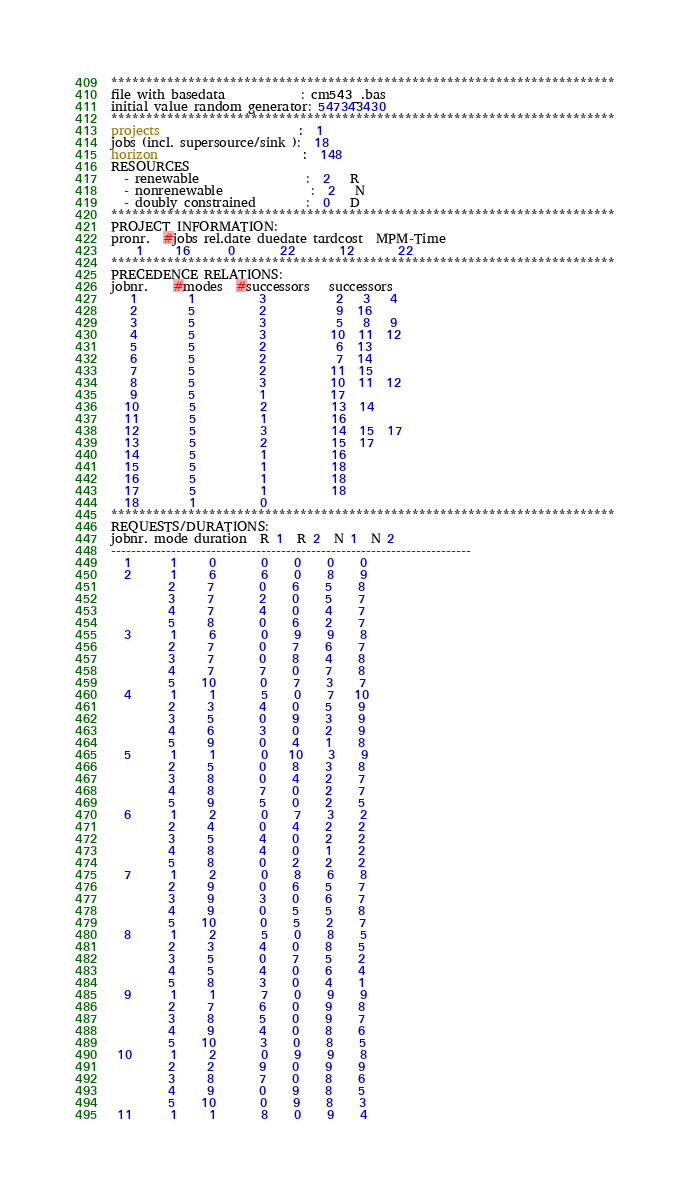<code> <loc_0><loc_0><loc_500><loc_500><_ObjectiveC_>************************************************************************
file with basedata            : cm543_.bas
initial value random generator: 547343430
************************************************************************
projects                      :  1
jobs (incl. supersource/sink ):  18
horizon                       :  148
RESOURCES
  - renewable                 :  2   R
  - nonrenewable              :  2   N
  - doubly constrained        :  0   D
************************************************************************
PROJECT INFORMATION:
pronr.  #jobs rel.date duedate tardcost  MPM-Time
    1     16      0       22       12       22
************************************************************************
PRECEDENCE RELATIONS:
jobnr.    #modes  #successors   successors
   1        1          3           2   3   4
   2        5          2           9  16
   3        5          3           5   8   9
   4        5          3          10  11  12
   5        5          2           6  13
   6        5          2           7  14
   7        5          2          11  15
   8        5          3          10  11  12
   9        5          1          17
  10        5          2          13  14
  11        5          1          16
  12        5          3          14  15  17
  13        5          2          15  17
  14        5          1          16
  15        5          1          18
  16        5          1          18
  17        5          1          18
  18        1          0        
************************************************************************
REQUESTS/DURATIONS:
jobnr. mode duration  R 1  R 2  N 1  N 2
------------------------------------------------------------------------
  1      1     0       0    0    0    0
  2      1     6       6    0    8    9
         2     7       0    6    5    8
         3     7       2    0    5    7
         4     7       4    0    4    7
         5     8       0    6    2    7
  3      1     6       0    9    9    8
         2     7       0    7    6    7
         3     7       0    8    4    8
         4     7       7    0    7    8
         5    10       0    7    3    7
  4      1     1       5    0    7   10
         2     3       4    0    5    9
         3     5       0    9    3    9
         4     6       3    0    2    9
         5     9       0    4    1    8
  5      1     1       0   10    3    9
         2     5       0    8    3    8
         3     8       0    4    2    7
         4     8       7    0    2    7
         5     9       5    0    2    5
  6      1     2       0    7    3    2
         2     4       0    4    2    2
         3     5       4    0    2    2
         4     8       4    0    1    2
         5     8       0    2    2    2
  7      1     2       0    8    6    8
         2     9       0    6    5    7
         3     9       3    0    6    7
         4     9       0    5    5    8
         5    10       0    5    2    7
  8      1     2       5    0    8    5
         2     3       4    0    8    5
         3     5       0    7    5    2
         4     5       4    0    6    4
         5     8       3    0    4    1
  9      1     1       7    0    9    9
         2     7       6    0    9    8
         3     8       5    0    9    7
         4     9       4    0    8    6
         5    10       3    0    8    5
 10      1     2       0    9    9    8
         2     2       9    0    9    9
         3     8       7    0    8    6
         4     9       0    9    8    5
         5    10       0    9    8    3
 11      1     1       8    0    9    4</code> 